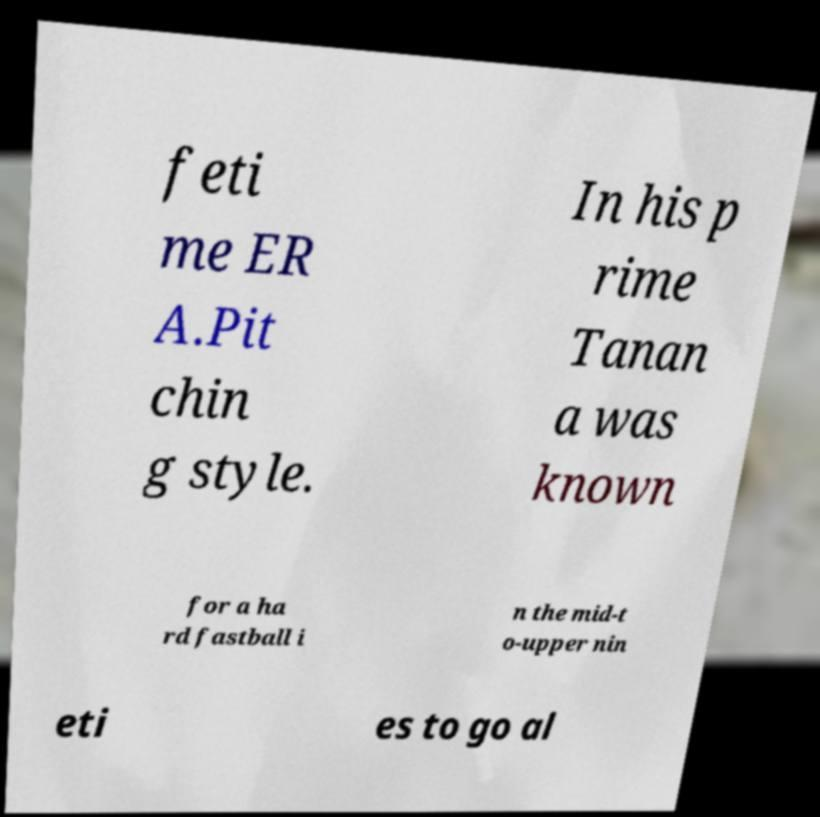Could you extract and type out the text from this image? feti me ER A.Pit chin g style. In his p rime Tanan a was known for a ha rd fastball i n the mid-t o-upper nin eti es to go al 